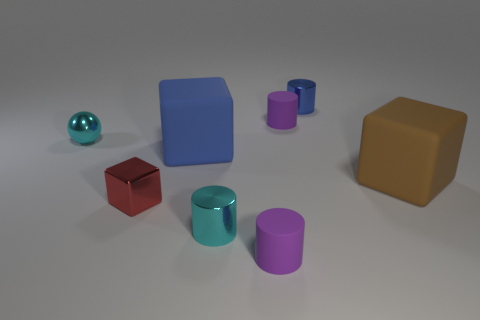Add 2 tiny shiny objects. How many objects exist? 10 Subtract all big brown rubber objects. Subtract all large cubes. How many objects are left? 5 Add 6 metal cylinders. How many metal cylinders are left? 8 Add 5 metallic cylinders. How many metallic cylinders exist? 7 Subtract all blue cylinders. How many cylinders are left? 3 Subtract all small blue metal cylinders. How many cylinders are left? 3 Subtract 0 yellow spheres. How many objects are left? 8 Subtract all blocks. How many objects are left? 5 Subtract 1 cylinders. How many cylinders are left? 3 Subtract all red spheres. Subtract all yellow cylinders. How many spheres are left? 1 